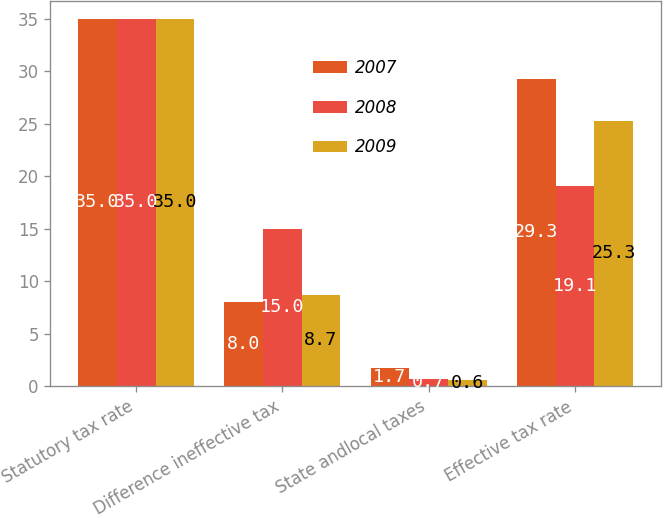Convert chart. <chart><loc_0><loc_0><loc_500><loc_500><stacked_bar_chart><ecel><fcel>Statutory tax rate<fcel>Difference ineffective tax<fcel>State andlocal taxes<fcel>Effective tax rate<nl><fcel>2007<fcel>35<fcel>8<fcel>1.7<fcel>29.3<nl><fcel>2008<fcel>35<fcel>15<fcel>0.7<fcel>19.1<nl><fcel>2009<fcel>35<fcel>8.7<fcel>0.6<fcel>25.3<nl></chart> 